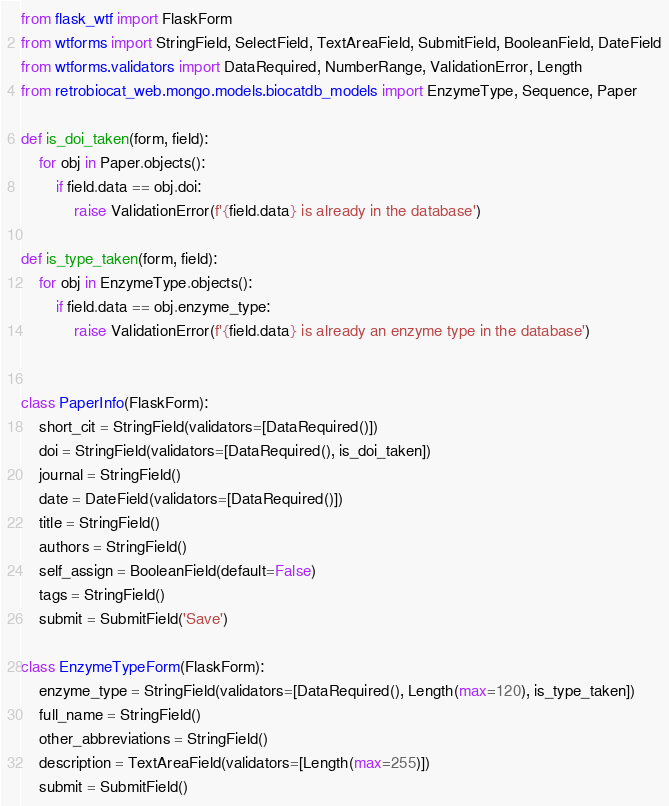Convert code to text. <code><loc_0><loc_0><loc_500><loc_500><_Python_>from flask_wtf import FlaskForm
from wtforms import StringField, SelectField, TextAreaField, SubmitField, BooleanField, DateField
from wtforms.validators import DataRequired, NumberRange, ValidationError, Length
from retrobiocat_web.mongo.models.biocatdb_models import EnzymeType, Sequence, Paper

def is_doi_taken(form, field):
    for obj in Paper.objects():
        if field.data == obj.doi:
            raise ValidationError(f'{field.data} is already in the database')

def is_type_taken(form, field):
    for obj in EnzymeType.objects():
        if field.data == obj.enzyme_type:
            raise ValidationError(f'{field.data} is already an enzyme type in the database')


class PaperInfo(FlaskForm):
    short_cit = StringField(validators=[DataRequired()])
    doi = StringField(validators=[DataRequired(), is_doi_taken])
    journal = StringField()
    date = DateField(validators=[DataRequired()])
    title = StringField()
    authors = StringField()
    self_assign = BooleanField(default=False)
    tags = StringField()
    submit = SubmitField('Save')

class EnzymeTypeForm(FlaskForm):
    enzyme_type = StringField(validators=[DataRequired(), Length(max=120), is_type_taken])
    full_name = StringField()
    other_abbreviations = StringField()
    description = TextAreaField(validators=[Length(max=255)])
    submit = SubmitField()</code> 